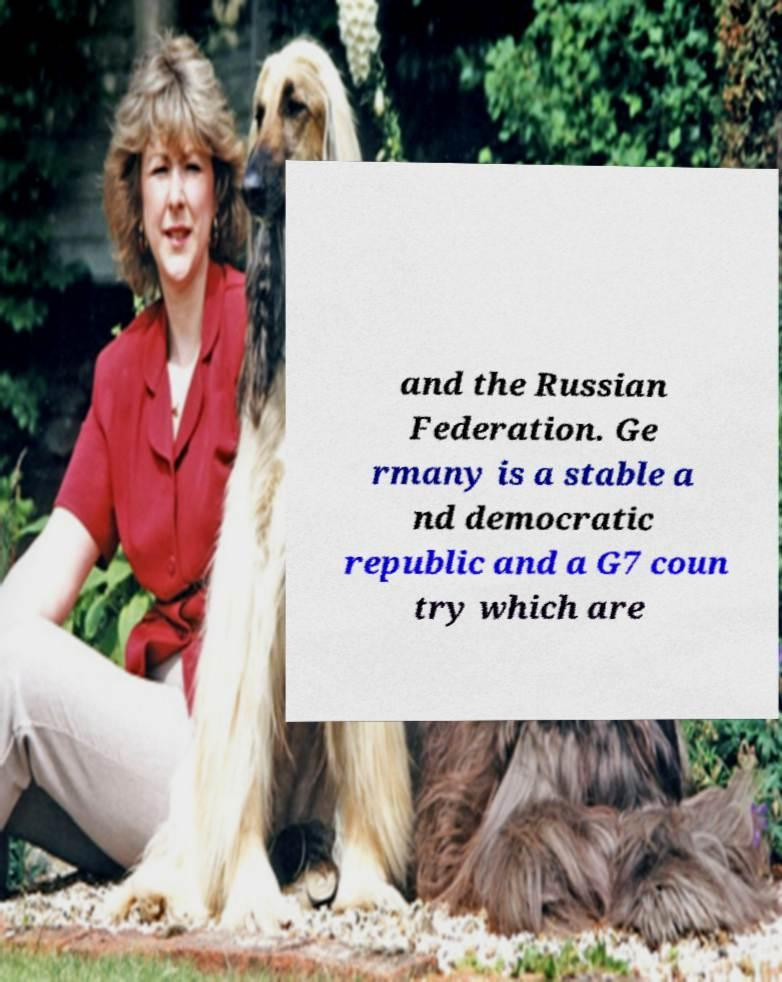Please read and relay the text visible in this image. What does it say? and the Russian Federation. Ge rmany is a stable a nd democratic republic and a G7 coun try which are 